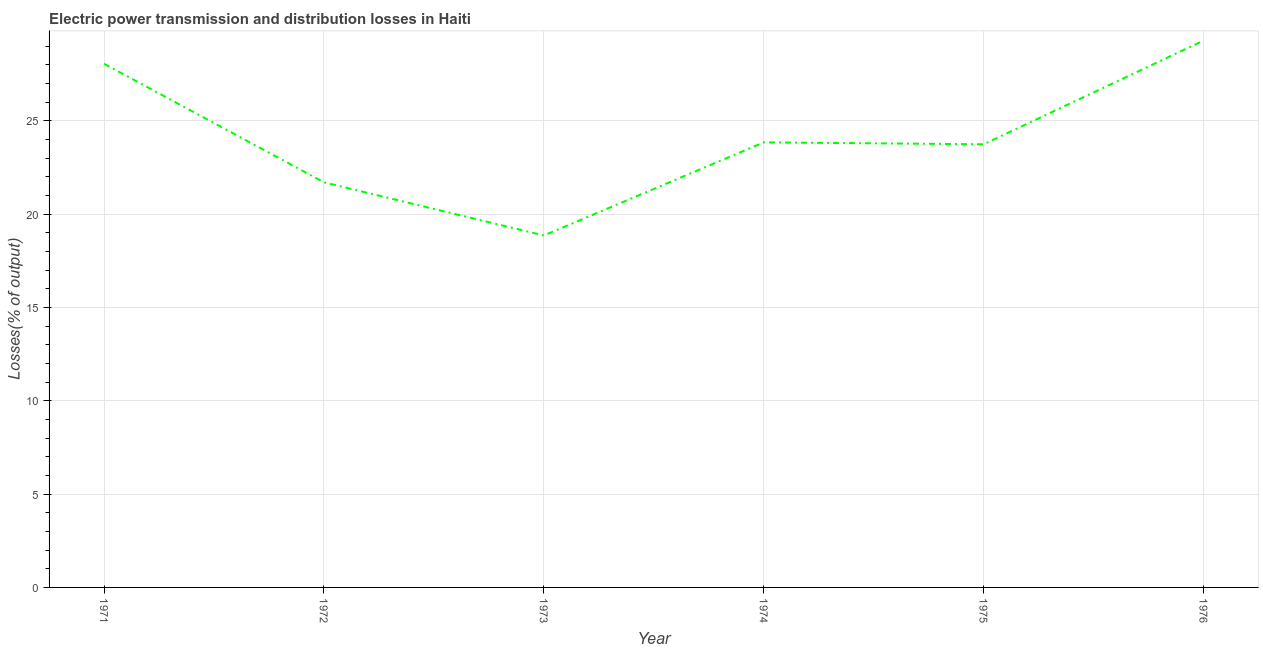What is the electric power transmission and distribution losses in 1972?
Make the answer very short. 21.7. Across all years, what is the maximum electric power transmission and distribution losses?
Your answer should be very brief. 29.29. Across all years, what is the minimum electric power transmission and distribution losses?
Ensure brevity in your answer.  18.85. In which year was the electric power transmission and distribution losses maximum?
Give a very brief answer. 1976. What is the sum of the electric power transmission and distribution losses?
Offer a very short reply. 145.47. What is the difference between the electric power transmission and distribution losses in 1972 and 1976?
Your answer should be compact. -7.59. What is the average electric power transmission and distribution losses per year?
Your answer should be very brief. 24.25. What is the median electric power transmission and distribution losses?
Make the answer very short. 23.79. In how many years, is the electric power transmission and distribution losses greater than 20 %?
Provide a succinct answer. 5. What is the ratio of the electric power transmission and distribution losses in 1971 to that in 1974?
Offer a terse response. 1.18. Is the electric power transmission and distribution losses in 1972 less than that in 1973?
Provide a succinct answer. No. What is the difference between the highest and the second highest electric power transmission and distribution losses?
Give a very brief answer. 1.24. What is the difference between the highest and the lowest electric power transmission and distribution losses?
Offer a terse response. 10.44. In how many years, is the electric power transmission and distribution losses greater than the average electric power transmission and distribution losses taken over all years?
Your answer should be very brief. 2. What is the difference between two consecutive major ticks on the Y-axis?
Make the answer very short. 5. Does the graph contain grids?
Your response must be concise. Yes. What is the title of the graph?
Offer a terse response. Electric power transmission and distribution losses in Haiti. What is the label or title of the Y-axis?
Give a very brief answer. Losses(% of output). What is the Losses(% of output) in 1971?
Keep it short and to the point. 28.05. What is the Losses(% of output) in 1972?
Keep it short and to the point. 21.7. What is the Losses(% of output) in 1973?
Provide a short and direct response. 18.85. What is the Losses(% of output) of 1974?
Make the answer very short. 23.84. What is the Losses(% of output) of 1975?
Make the answer very short. 23.74. What is the Losses(% of output) of 1976?
Offer a very short reply. 29.29. What is the difference between the Losses(% of output) in 1971 and 1972?
Ensure brevity in your answer.  6.35. What is the difference between the Losses(% of output) in 1971 and 1973?
Provide a succinct answer. 9.2. What is the difference between the Losses(% of output) in 1971 and 1974?
Your answer should be very brief. 4.21. What is the difference between the Losses(% of output) in 1971 and 1975?
Offer a very short reply. 4.31. What is the difference between the Losses(% of output) in 1971 and 1976?
Offer a terse response. -1.24. What is the difference between the Losses(% of output) in 1972 and 1973?
Give a very brief answer. 2.85. What is the difference between the Losses(% of output) in 1972 and 1974?
Offer a very short reply. -2.14. What is the difference between the Losses(% of output) in 1972 and 1975?
Keep it short and to the point. -2.04. What is the difference between the Losses(% of output) in 1972 and 1976?
Offer a very short reply. -7.59. What is the difference between the Losses(% of output) in 1973 and 1974?
Your response must be concise. -4.99. What is the difference between the Losses(% of output) in 1973 and 1975?
Offer a very short reply. -4.88. What is the difference between the Losses(% of output) in 1973 and 1976?
Provide a succinct answer. -10.44. What is the difference between the Losses(% of output) in 1974 and 1975?
Offer a very short reply. 0.1. What is the difference between the Losses(% of output) in 1974 and 1976?
Provide a short and direct response. -5.45. What is the difference between the Losses(% of output) in 1975 and 1976?
Keep it short and to the point. -5.56. What is the ratio of the Losses(% of output) in 1971 to that in 1972?
Provide a short and direct response. 1.29. What is the ratio of the Losses(% of output) in 1971 to that in 1973?
Provide a short and direct response. 1.49. What is the ratio of the Losses(% of output) in 1971 to that in 1974?
Your answer should be very brief. 1.18. What is the ratio of the Losses(% of output) in 1971 to that in 1975?
Your answer should be very brief. 1.18. What is the ratio of the Losses(% of output) in 1971 to that in 1976?
Your response must be concise. 0.96. What is the ratio of the Losses(% of output) in 1972 to that in 1973?
Your answer should be very brief. 1.15. What is the ratio of the Losses(% of output) in 1972 to that in 1974?
Give a very brief answer. 0.91. What is the ratio of the Losses(% of output) in 1972 to that in 1975?
Provide a succinct answer. 0.91. What is the ratio of the Losses(% of output) in 1972 to that in 1976?
Ensure brevity in your answer.  0.74. What is the ratio of the Losses(% of output) in 1973 to that in 1974?
Your response must be concise. 0.79. What is the ratio of the Losses(% of output) in 1973 to that in 1975?
Offer a terse response. 0.79. What is the ratio of the Losses(% of output) in 1973 to that in 1976?
Your response must be concise. 0.64. What is the ratio of the Losses(% of output) in 1974 to that in 1976?
Make the answer very short. 0.81. What is the ratio of the Losses(% of output) in 1975 to that in 1976?
Ensure brevity in your answer.  0.81. 